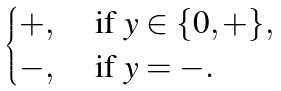<formula> <loc_0><loc_0><loc_500><loc_500>\begin{cases} + , & \text { if } y \in \{ 0 , + \} , \\ - , & \text { if } y = - . \end{cases}</formula> 